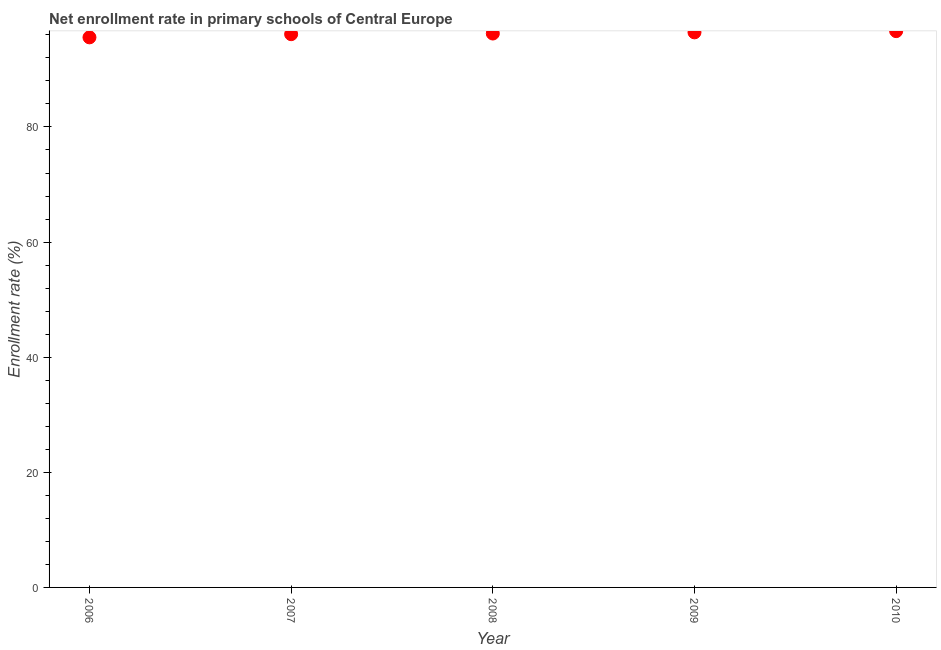What is the net enrollment rate in primary schools in 2008?
Provide a short and direct response. 96.23. Across all years, what is the maximum net enrollment rate in primary schools?
Make the answer very short. 96.65. Across all years, what is the minimum net enrollment rate in primary schools?
Your response must be concise. 95.57. In which year was the net enrollment rate in primary schools maximum?
Make the answer very short. 2010. What is the sum of the net enrollment rate in primary schools?
Ensure brevity in your answer.  481.01. What is the difference between the net enrollment rate in primary schools in 2008 and 2009?
Provide a succinct answer. -0.2. What is the average net enrollment rate in primary schools per year?
Give a very brief answer. 96.2. What is the median net enrollment rate in primary schools?
Your response must be concise. 96.23. What is the ratio of the net enrollment rate in primary schools in 2008 to that in 2009?
Keep it short and to the point. 1. Is the net enrollment rate in primary schools in 2006 less than that in 2008?
Your answer should be compact. Yes. Is the difference between the net enrollment rate in primary schools in 2007 and 2009 greater than the difference between any two years?
Offer a terse response. No. What is the difference between the highest and the second highest net enrollment rate in primary schools?
Ensure brevity in your answer.  0.21. Is the sum of the net enrollment rate in primary schools in 2009 and 2010 greater than the maximum net enrollment rate in primary schools across all years?
Provide a succinct answer. Yes. What is the difference between the highest and the lowest net enrollment rate in primary schools?
Your answer should be very brief. 1.08. In how many years, is the net enrollment rate in primary schools greater than the average net enrollment rate in primary schools taken over all years?
Give a very brief answer. 3. Does the net enrollment rate in primary schools monotonically increase over the years?
Offer a terse response. Yes. How many dotlines are there?
Your response must be concise. 1. How many years are there in the graph?
Offer a terse response. 5. Are the values on the major ticks of Y-axis written in scientific E-notation?
Give a very brief answer. No. Does the graph contain any zero values?
Keep it short and to the point. No. Does the graph contain grids?
Provide a succinct answer. No. What is the title of the graph?
Your answer should be compact. Net enrollment rate in primary schools of Central Europe. What is the label or title of the X-axis?
Offer a very short reply. Year. What is the label or title of the Y-axis?
Give a very brief answer. Enrollment rate (%). What is the Enrollment rate (%) in 2006?
Provide a short and direct response. 95.57. What is the Enrollment rate (%) in 2007?
Ensure brevity in your answer.  96.12. What is the Enrollment rate (%) in 2008?
Keep it short and to the point. 96.23. What is the Enrollment rate (%) in 2009?
Provide a short and direct response. 96.44. What is the Enrollment rate (%) in 2010?
Offer a very short reply. 96.65. What is the difference between the Enrollment rate (%) in 2006 and 2007?
Ensure brevity in your answer.  -0.55. What is the difference between the Enrollment rate (%) in 2006 and 2008?
Offer a very short reply. -0.67. What is the difference between the Enrollment rate (%) in 2006 and 2009?
Your answer should be very brief. -0.87. What is the difference between the Enrollment rate (%) in 2006 and 2010?
Offer a very short reply. -1.08. What is the difference between the Enrollment rate (%) in 2007 and 2008?
Your answer should be very brief. -0.12. What is the difference between the Enrollment rate (%) in 2007 and 2009?
Keep it short and to the point. -0.32. What is the difference between the Enrollment rate (%) in 2007 and 2010?
Provide a short and direct response. -0.53. What is the difference between the Enrollment rate (%) in 2008 and 2009?
Your answer should be compact. -0.2. What is the difference between the Enrollment rate (%) in 2008 and 2010?
Keep it short and to the point. -0.42. What is the difference between the Enrollment rate (%) in 2009 and 2010?
Provide a short and direct response. -0.21. What is the ratio of the Enrollment rate (%) in 2006 to that in 2009?
Ensure brevity in your answer.  0.99. What is the ratio of the Enrollment rate (%) in 2006 to that in 2010?
Provide a short and direct response. 0.99. What is the ratio of the Enrollment rate (%) in 2007 to that in 2008?
Provide a short and direct response. 1. What is the ratio of the Enrollment rate (%) in 2008 to that in 2009?
Make the answer very short. 1. What is the ratio of the Enrollment rate (%) in 2008 to that in 2010?
Provide a succinct answer. 1. What is the ratio of the Enrollment rate (%) in 2009 to that in 2010?
Your answer should be very brief. 1. 